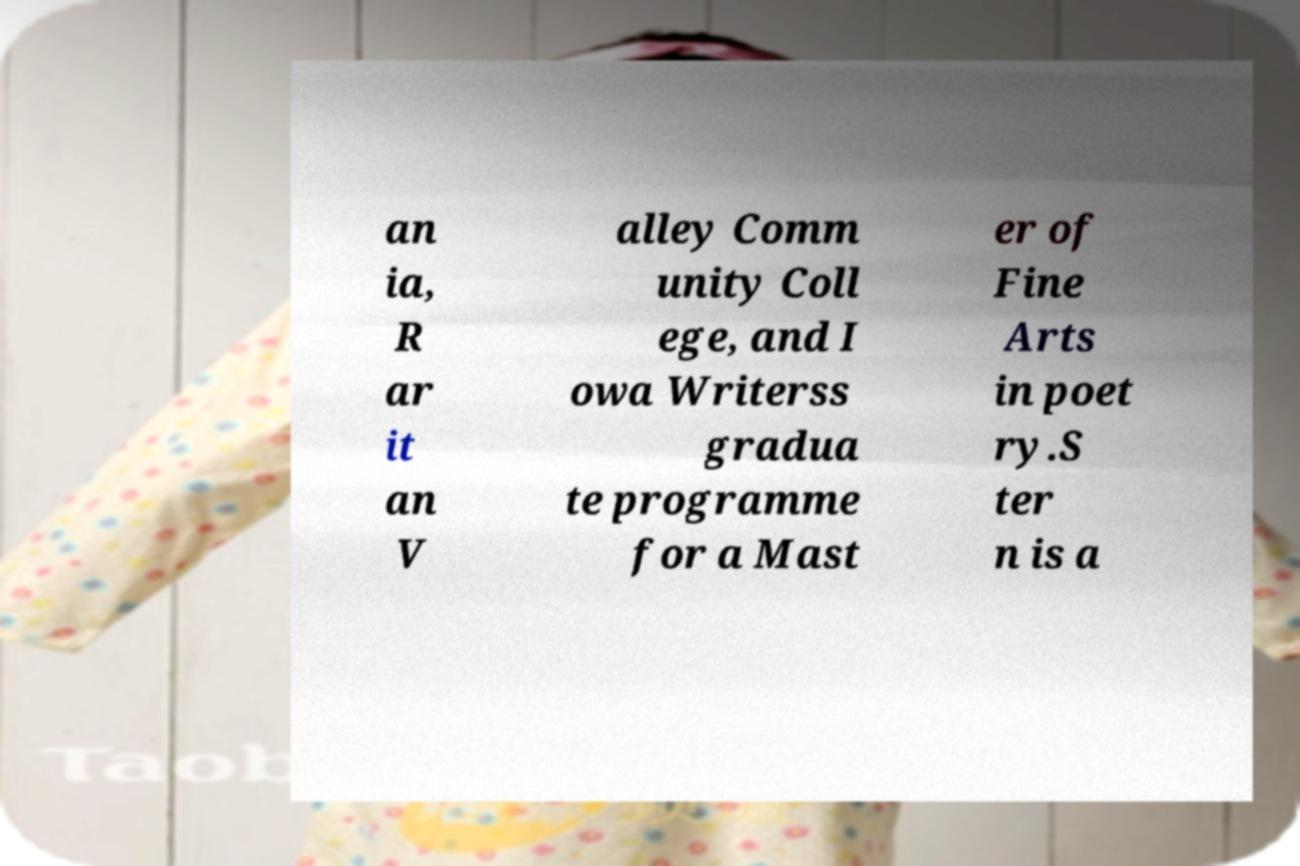Please read and relay the text visible in this image. What does it say? an ia, R ar it an V alley Comm unity Coll ege, and I owa Writerss gradua te programme for a Mast er of Fine Arts in poet ry.S ter n is a 